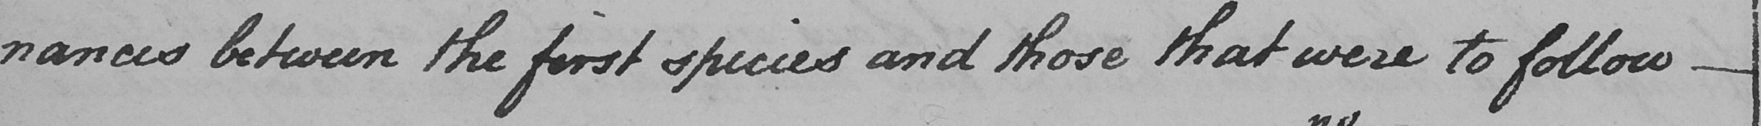Please provide the text content of this handwritten line. -nances between the first species and those that were to follow  _ 